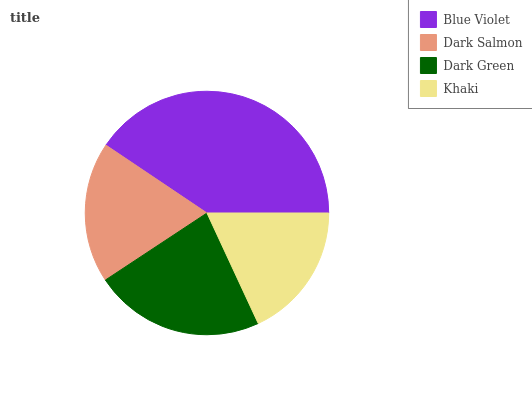Is Khaki the minimum?
Answer yes or no. Yes. Is Blue Violet the maximum?
Answer yes or no. Yes. Is Dark Salmon the minimum?
Answer yes or no. No. Is Dark Salmon the maximum?
Answer yes or no. No. Is Blue Violet greater than Dark Salmon?
Answer yes or no. Yes. Is Dark Salmon less than Blue Violet?
Answer yes or no. Yes. Is Dark Salmon greater than Blue Violet?
Answer yes or no. No. Is Blue Violet less than Dark Salmon?
Answer yes or no. No. Is Dark Green the high median?
Answer yes or no. Yes. Is Dark Salmon the low median?
Answer yes or no. Yes. Is Khaki the high median?
Answer yes or no. No. Is Khaki the low median?
Answer yes or no. No. 